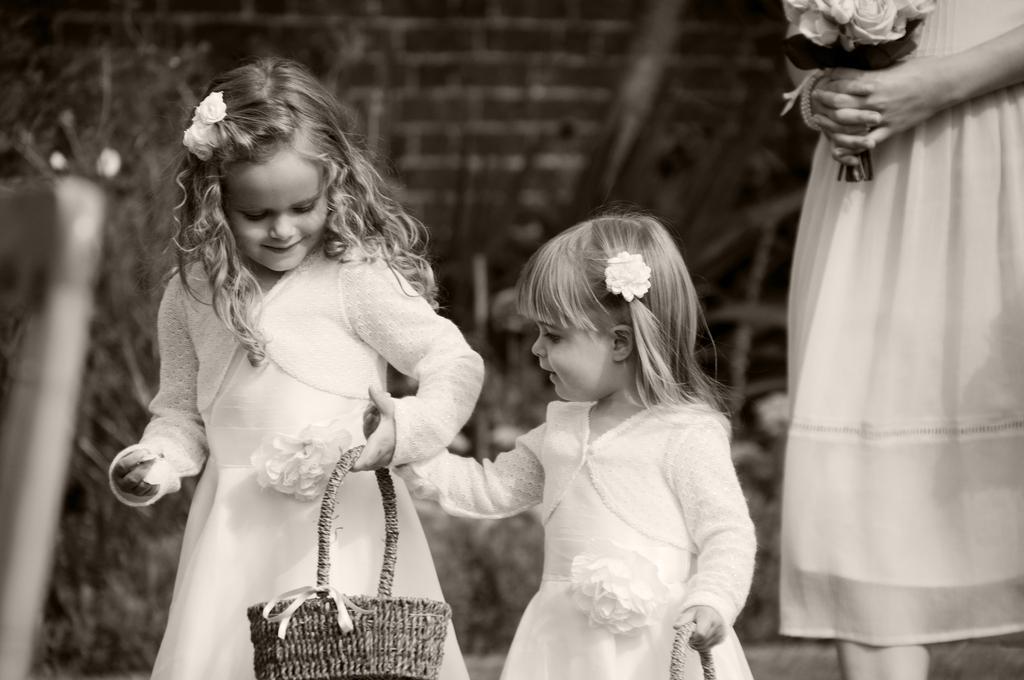Please provide a concise description of this image. This is a black and white image. I can see two girls holding a basket and standing. On the right side of the image, there is another person holding a flower bouquet and standing. The background looks blurry. 